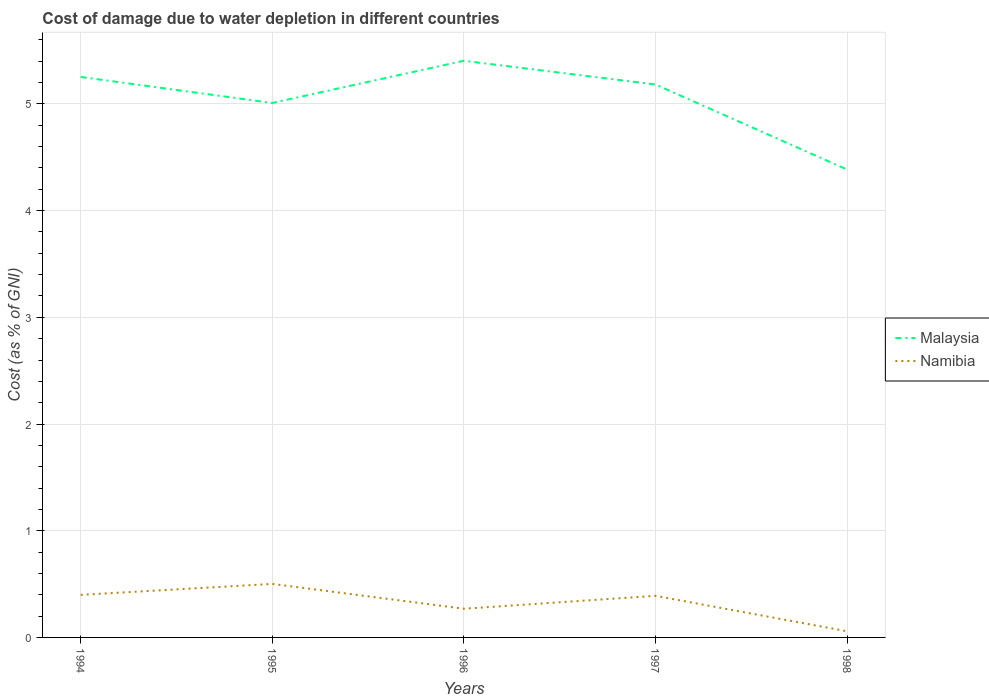How many different coloured lines are there?
Your answer should be compact. 2. Is the number of lines equal to the number of legend labels?
Give a very brief answer. Yes. Across all years, what is the maximum cost of damage caused due to water depletion in Namibia?
Your answer should be compact. 0.06. In which year was the cost of damage caused due to water depletion in Namibia maximum?
Ensure brevity in your answer.  1998. What is the total cost of damage caused due to water depletion in Namibia in the graph?
Make the answer very short. 0.13. What is the difference between the highest and the second highest cost of damage caused due to water depletion in Namibia?
Make the answer very short. 0.44. What is the difference between the highest and the lowest cost of damage caused due to water depletion in Malaysia?
Your response must be concise. 3. How many years are there in the graph?
Provide a succinct answer. 5. What is the difference between two consecutive major ticks on the Y-axis?
Offer a terse response. 1. How many legend labels are there?
Offer a very short reply. 2. What is the title of the graph?
Offer a terse response. Cost of damage due to water depletion in different countries. What is the label or title of the X-axis?
Your answer should be compact. Years. What is the label or title of the Y-axis?
Ensure brevity in your answer.  Cost (as % of GNI). What is the Cost (as % of GNI) of Malaysia in 1994?
Provide a short and direct response. 5.25. What is the Cost (as % of GNI) of Namibia in 1994?
Keep it short and to the point. 0.4. What is the Cost (as % of GNI) in Malaysia in 1995?
Ensure brevity in your answer.  5.01. What is the Cost (as % of GNI) in Namibia in 1995?
Your response must be concise. 0.5. What is the Cost (as % of GNI) in Malaysia in 1996?
Make the answer very short. 5.4. What is the Cost (as % of GNI) in Namibia in 1996?
Ensure brevity in your answer.  0.27. What is the Cost (as % of GNI) of Malaysia in 1997?
Ensure brevity in your answer.  5.18. What is the Cost (as % of GNI) of Namibia in 1997?
Offer a terse response. 0.39. What is the Cost (as % of GNI) of Malaysia in 1998?
Provide a succinct answer. 4.39. What is the Cost (as % of GNI) of Namibia in 1998?
Offer a terse response. 0.06. Across all years, what is the maximum Cost (as % of GNI) of Malaysia?
Give a very brief answer. 5.4. Across all years, what is the maximum Cost (as % of GNI) of Namibia?
Keep it short and to the point. 0.5. Across all years, what is the minimum Cost (as % of GNI) in Malaysia?
Provide a short and direct response. 4.39. Across all years, what is the minimum Cost (as % of GNI) in Namibia?
Ensure brevity in your answer.  0.06. What is the total Cost (as % of GNI) in Malaysia in the graph?
Keep it short and to the point. 25.23. What is the total Cost (as % of GNI) in Namibia in the graph?
Provide a succinct answer. 1.62. What is the difference between the Cost (as % of GNI) in Malaysia in 1994 and that in 1995?
Your answer should be compact. 0.24. What is the difference between the Cost (as % of GNI) of Namibia in 1994 and that in 1995?
Keep it short and to the point. -0.1. What is the difference between the Cost (as % of GNI) of Malaysia in 1994 and that in 1996?
Provide a short and direct response. -0.15. What is the difference between the Cost (as % of GNI) in Namibia in 1994 and that in 1996?
Keep it short and to the point. 0.13. What is the difference between the Cost (as % of GNI) in Malaysia in 1994 and that in 1997?
Give a very brief answer. 0.07. What is the difference between the Cost (as % of GNI) of Namibia in 1994 and that in 1997?
Your answer should be very brief. 0.01. What is the difference between the Cost (as % of GNI) in Malaysia in 1994 and that in 1998?
Provide a succinct answer. 0.87. What is the difference between the Cost (as % of GNI) in Namibia in 1994 and that in 1998?
Keep it short and to the point. 0.34. What is the difference between the Cost (as % of GNI) in Malaysia in 1995 and that in 1996?
Provide a succinct answer. -0.4. What is the difference between the Cost (as % of GNI) in Namibia in 1995 and that in 1996?
Provide a succinct answer. 0.23. What is the difference between the Cost (as % of GNI) in Malaysia in 1995 and that in 1997?
Give a very brief answer. -0.17. What is the difference between the Cost (as % of GNI) of Namibia in 1995 and that in 1997?
Offer a very short reply. 0.11. What is the difference between the Cost (as % of GNI) in Malaysia in 1995 and that in 1998?
Your response must be concise. 0.62. What is the difference between the Cost (as % of GNI) in Namibia in 1995 and that in 1998?
Give a very brief answer. 0.44. What is the difference between the Cost (as % of GNI) of Malaysia in 1996 and that in 1997?
Give a very brief answer. 0.22. What is the difference between the Cost (as % of GNI) of Namibia in 1996 and that in 1997?
Keep it short and to the point. -0.12. What is the difference between the Cost (as % of GNI) in Malaysia in 1996 and that in 1998?
Keep it short and to the point. 1.02. What is the difference between the Cost (as % of GNI) in Namibia in 1996 and that in 1998?
Provide a succinct answer. 0.21. What is the difference between the Cost (as % of GNI) of Malaysia in 1997 and that in 1998?
Your answer should be compact. 0.8. What is the difference between the Cost (as % of GNI) in Namibia in 1997 and that in 1998?
Offer a very short reply. 0.33. What is the difference between the Cost (as % of GNI) in Malaysia in 1994 and the Cost (as % of GNI) in Namibia in 1995?
Make the answer very short. 4.75. What is the difference between the Cost (as % of GNI) of Malaysia in 1994 and the Cost (as % of GNI) of Namibia in 1996?
Provide a succinct answer. 4.98. What is the difference between the Cost (as % of GNI) of Malaysia in 1994 and the Cost (as % of GNI) of Namibia in 1997?
Your response must be concise. 4.86. What is the difference between the Cost (as % of GNI) in Malaysia in 1994 and the Cost (as % of GNI) in Namibia in 1998?
Your response must be concise. 5.2. What is the difference between the Cost (as % of GNI) in Malaysia in 1995 and the Cost (as % of GNI) in Namibia in 1996?
Offer a terse response. 4.74. What is the difference between the Cost (as % of GNI) of Malaysia in 1995 and the Cost (as % of GNI) of Namibia in 1997?
Keep it short and to the point. 4.62. What is the difference between the Cost (as % of GNI) in Malaysia in 1995 and the Cost (as % of GNI) in Namibia in 1998?
Give a very brief answer. 4.95. What is the difference between the Cost (as % of GNI) of Malaysia in 1996 and the Cost (as % of GNI) of Namibia in 1997?
Keep it short and to the point. 5.01. What is the difference between the Cost (as % of GNI) in Malaysia in 1996 and the Cost (as % of GNI) in Namibia in 1998?
Provide a short and direct response. 5.35. What is the difference between the Cost (as % of GNI) of Malaysia in 1997 and the Cost (as % of GNI) of Namibia in 1998?
Keep it short and to the point. 5.12. What is the average Cost (as % of GNI) in Malaysia per year?
Ensure brevity in your answer.  5.05. What is the average Cost (as % of GNI) in Namibia per year?
Make the answer very short. 0.32. In the year 1994, what is the difference between the Cost (as % of GNI) in Malaysia and Cost (as % of GNI) in Namibia?
Your response must be concise. 4.85. In the year 1995, what is the difference between the Cost (as % of GNI) in Malaysia and Cost (as % of GNI) in Namibia?
Provide a succinct answer. 4.51. In the year 1996, what is the difference between the Cost (as % of GNI) in Malaysia and Cost (as % of GNI) in Namibia?
Keep it short and to the point. 5.14. In the year 1997, what is the difference between the Cost (as % of GNI) in Malaysia and Cost (as % of GNI) in Namibia?
Ensure brevity in your answer.  4.79. In the year 1998, what is the difference between the Cost (as % of GNI) of Malaysia and Cost (as % of GNI) of Namibia?
Provide a short and direct response. 4.33. What is the ratio of the Cost (as % of GNI) of Malaysia in 1994 to that in 1995?
Your response must be concise. 1.05. What is the ratio of the Cost (as % of GNI) in Namibia in 1994 to that in 1995?
Your answer should be compact. 0.8. What is the ratio of the Cost (as % of GNI) in Namibia in 1994 to that in 1996?
Offer a very short reply. 1.48. What is the ratio of the Cost (as % of GNI) of Malaysia in 1994 to that in 1997?
Your answer should be very brief. 1.01. What is the ratio of the Cost (as % of GNI) in Namibia in 1994 to that in 1997?
Your response must be concise. 1.02. What is the ratio of the Cost (as % of GNI) of Malaysia in 1994 to that in 1998?
Provide a short and direct response. 1.2. What is the ratio of the Cost (as % of GNI) of Namibia in 1994 to that in 1998?
Provide a succinct answer. 6.9. What is the ratio of the Cost (as % of GNI) of Malaysia in 1995 to that in 1996?
Keep it short and to the point. 0.93. What is the ratio of the Cost (as % of GNI) of Namibia in 1995 to that in 1996?
Provide a short and direct response. 1.86. What is the ratio of the Cost (as % of GNI) of Malaysia in 1995 to that in 1997?
Your response must be concise. 0.97. What is the ratio of the Cost (as % of GNI) in Namibia in 1995 to that in 1997?
Your answer should be very brief. 1.29. What is the ratio of the Cost (as % of GNI) in Malaysia in 1995 to that in 1998?
Make the answer very short. 1.14. What is the ratio of the Cost (as % of GNI) in Namibia in 1995 to that in 1998?
Ensure brevity in your answer.  8.67. What is the ratio of the Cost (as % of GNI) of Malaysia in 1996 to that in 1997?
Ensure brevity in your answer.  1.04. What is the ratio of the Cost (as % of GNI) in Namibia in 1996 to that in 1997?
Offer a very short reply. 0.69. What is the ratio of the Cost (as % of GNI) in Malaysia in 1996 to that in 1998?
Offer a terse response. 1.23. What is the ratio of the Cost (as % of GNI) in Namibia in 1996 to that in 1998?
Offer a terse response. 4.65. What is the ratio of the Cost (as % of GNI) of Malaysia in 1997 to that in 1998?
Keep it short and to the point. 1.18. What is the ratio of the Cost (as % of GNI) in Namibia in 1997 to that in 1998?
Your answer should be compact. 6.74. What is the difference between the highest and the second highest Cost (as % of GNI) of Malaysia?
Provide a succinct answer. 0.15. What is the difference between the highest and the second highest Cost (as % of GNI) in Namibia?
Make the answer very short. 0.1. What is the difference between the highest and the lowest Cost (as % of GNI) in Malaysia?
Provide a short and direct response. 1.02. What is the difference between the highest and the lowest Cost (as % of GNI) of Namibia?
Keep it short and to the point. 0.44. 